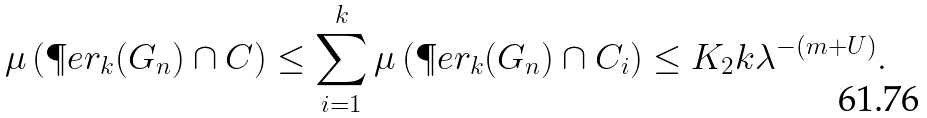Convert formula to latex. <formula><loc_0><loc_0><loc_500><loc_500>\mu \left ( \P e r _ { k } ( G _ { n } ) \cap C \right ) \leq \sum _ { i = 1 } ^ { k } \mu \left ( \P e r _ { k } ( G _ { n } ) \cap C _ { i } \right ) \leq K _ { 2 } k \lambda ^ { - ( m + U ) } .</formula> 